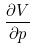Convert formula to latex. <formula><loc_0><loc_0><loc_500><loc_500>\frac { \partial V } { \partial p }</formula> 